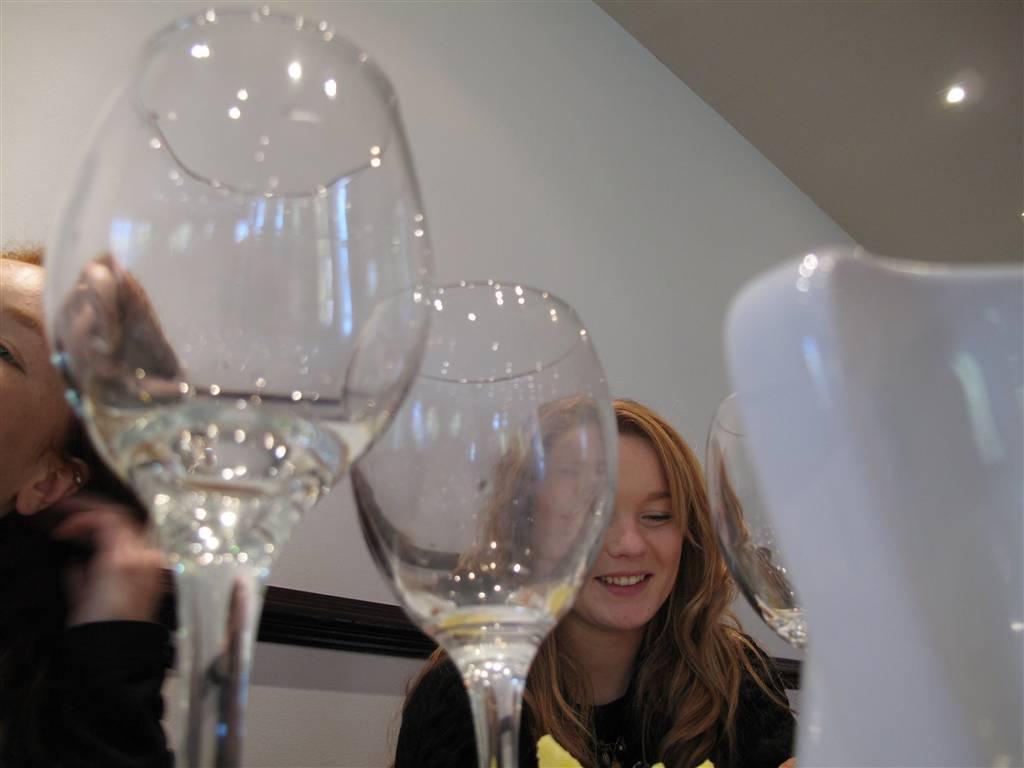Please provide a concise description of this image. Here we can see glasses and two persons. She is smiling. In the background we can see wall and a light. 